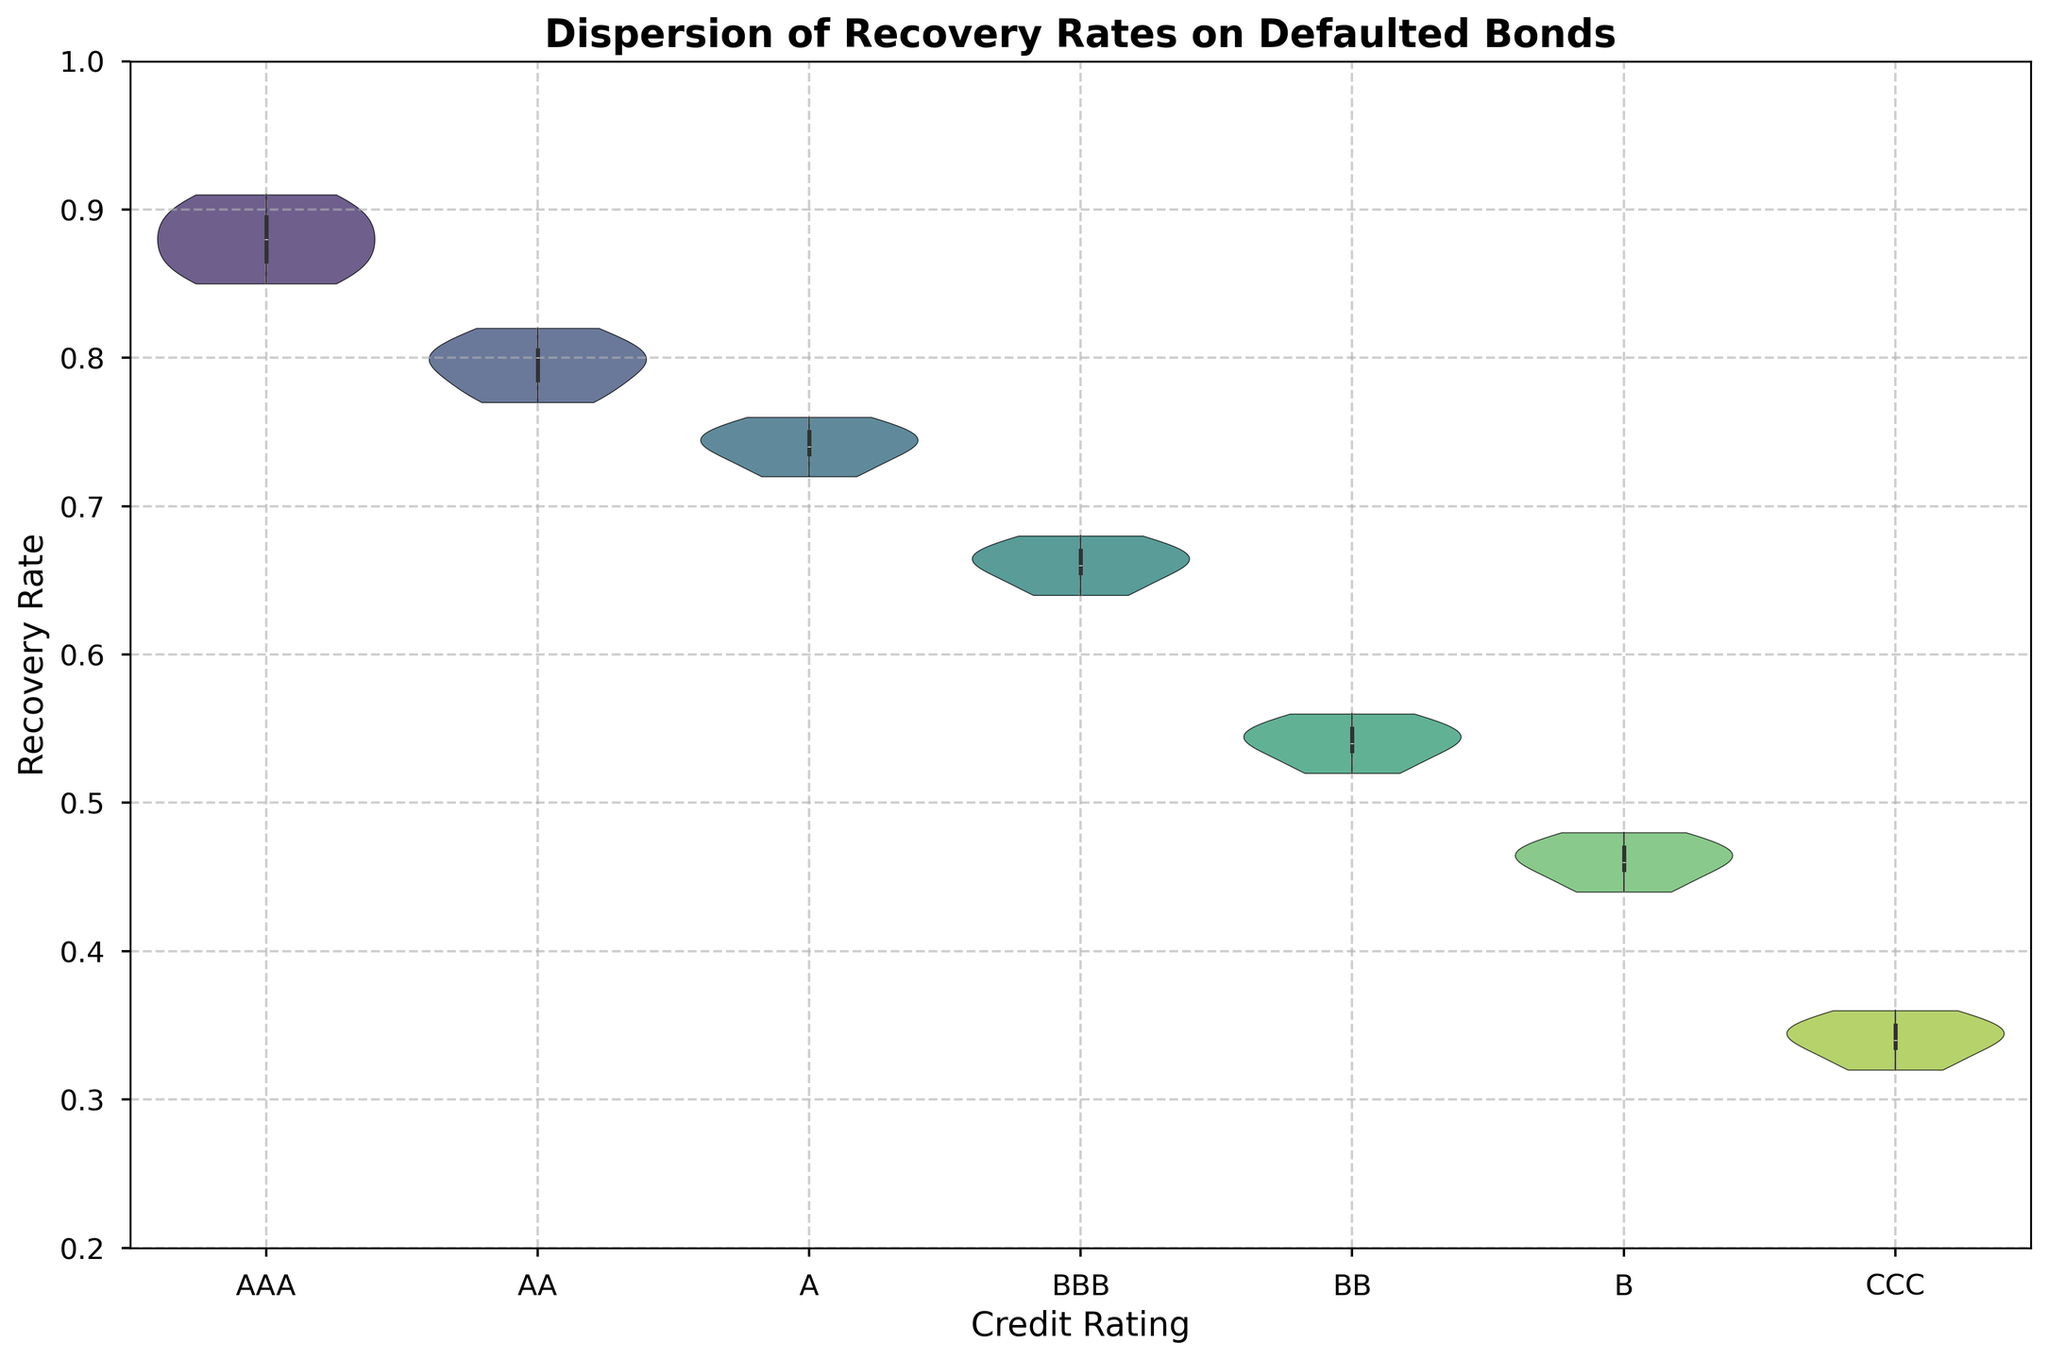What is the title of the figure? The title is usually found at the top of the figure, in this case, it reads "Dispersion of Recovery Rates on Defaulted Bonds".
Answer: Dispersion of Recovery Rates on Defaulted Bonds Which credit rating category has the highest median recovery rate? In a violin plot, the median is denoted by a white dot inside the wider part of the violin. For the given figure, the AAA category shows the highest white dot.
Answer: AAA How many tick marks are there on the y-axis? Each tick mark can be clearly seen on the y-axis, spaced evenly from 0.2 to 1.0 at intervals of 0.1. There are ten marks: 0.2, 0.3, 0.4, 0.5, 0.6, 0.7, 0.8, 0.9, 1.0.
Answer: 9 Which two credit rating categories have the most similar recovery rate distributions? By examining the spread and shape of the violins, AA and A have very similar distributions, as they both show similar bandwidths and shape symmetry.
Answer: AA and A What is the general trend of recovery rates as credit ratings decrease? Observing the plot from left to right (AAA to CCC), there's a general downward trend in recovery rates. Violin plots shift lower as credit ratings decrease.
Answer: Decreasing Which category has the widest range of recovery rates? The range of recovery rates is indicated by the length of the violin. The largest and more elongated violin, showing the widest range, is for AA.
Answer: AA What is the interquartile range (IQR) of recovery rates for BBB? The IQR, indicated on a violin plot by the width of the violin around the middle 50% of the data (between the lower and upper quartiles). In BBB, this area can be identified easily as the widest section in the middle.
Answer: Approx 0.64 to 0.68 How does the recovery rate distribution of CCC compare to AAA? Comparing these two categories, CCC has a much lower and more compressed distribution, while AAA's distribution is higher and less compressed.
Answer: CCC is lower and more compressed Which credit rating has the least variation in recovery rates? The variation can be judged by the width and spread of the violin. The narrowest and least spread violin indicates low variation. For this figure, AAA has the least variation.
Answer: AAA Are there any credit rating categories with recovery rates below 0.5? By looking at the y-axis of the figure, one can see that anything below 0.5 falls into the B and CCC credit rating categories.
Answer: B and CCC 